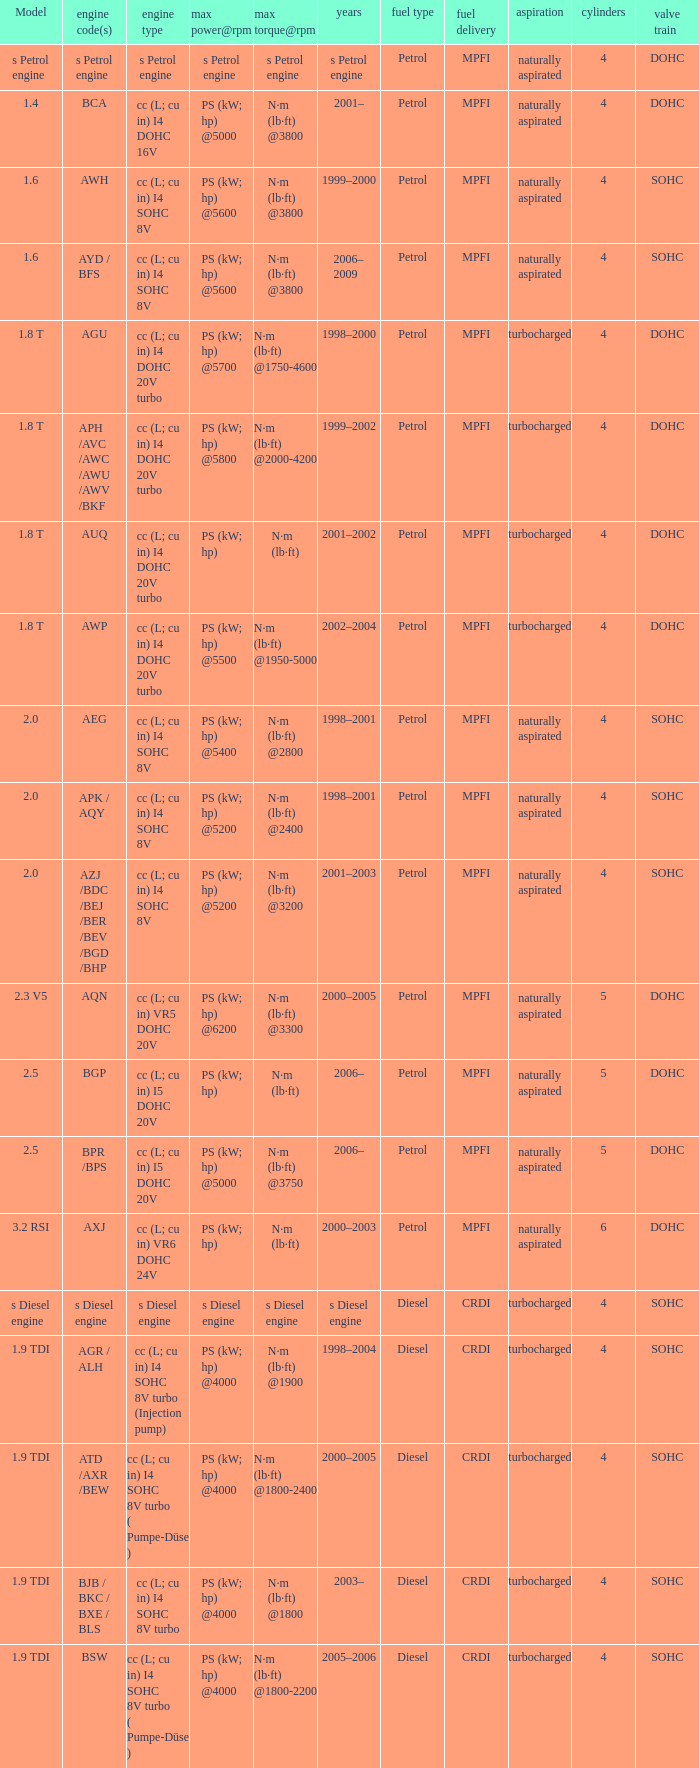What was the max torque@rpm of the engine which had the model 2.5  and a max power@rpm of ps (kw; hp) @5000? N·m (lb·ft) @3750. 